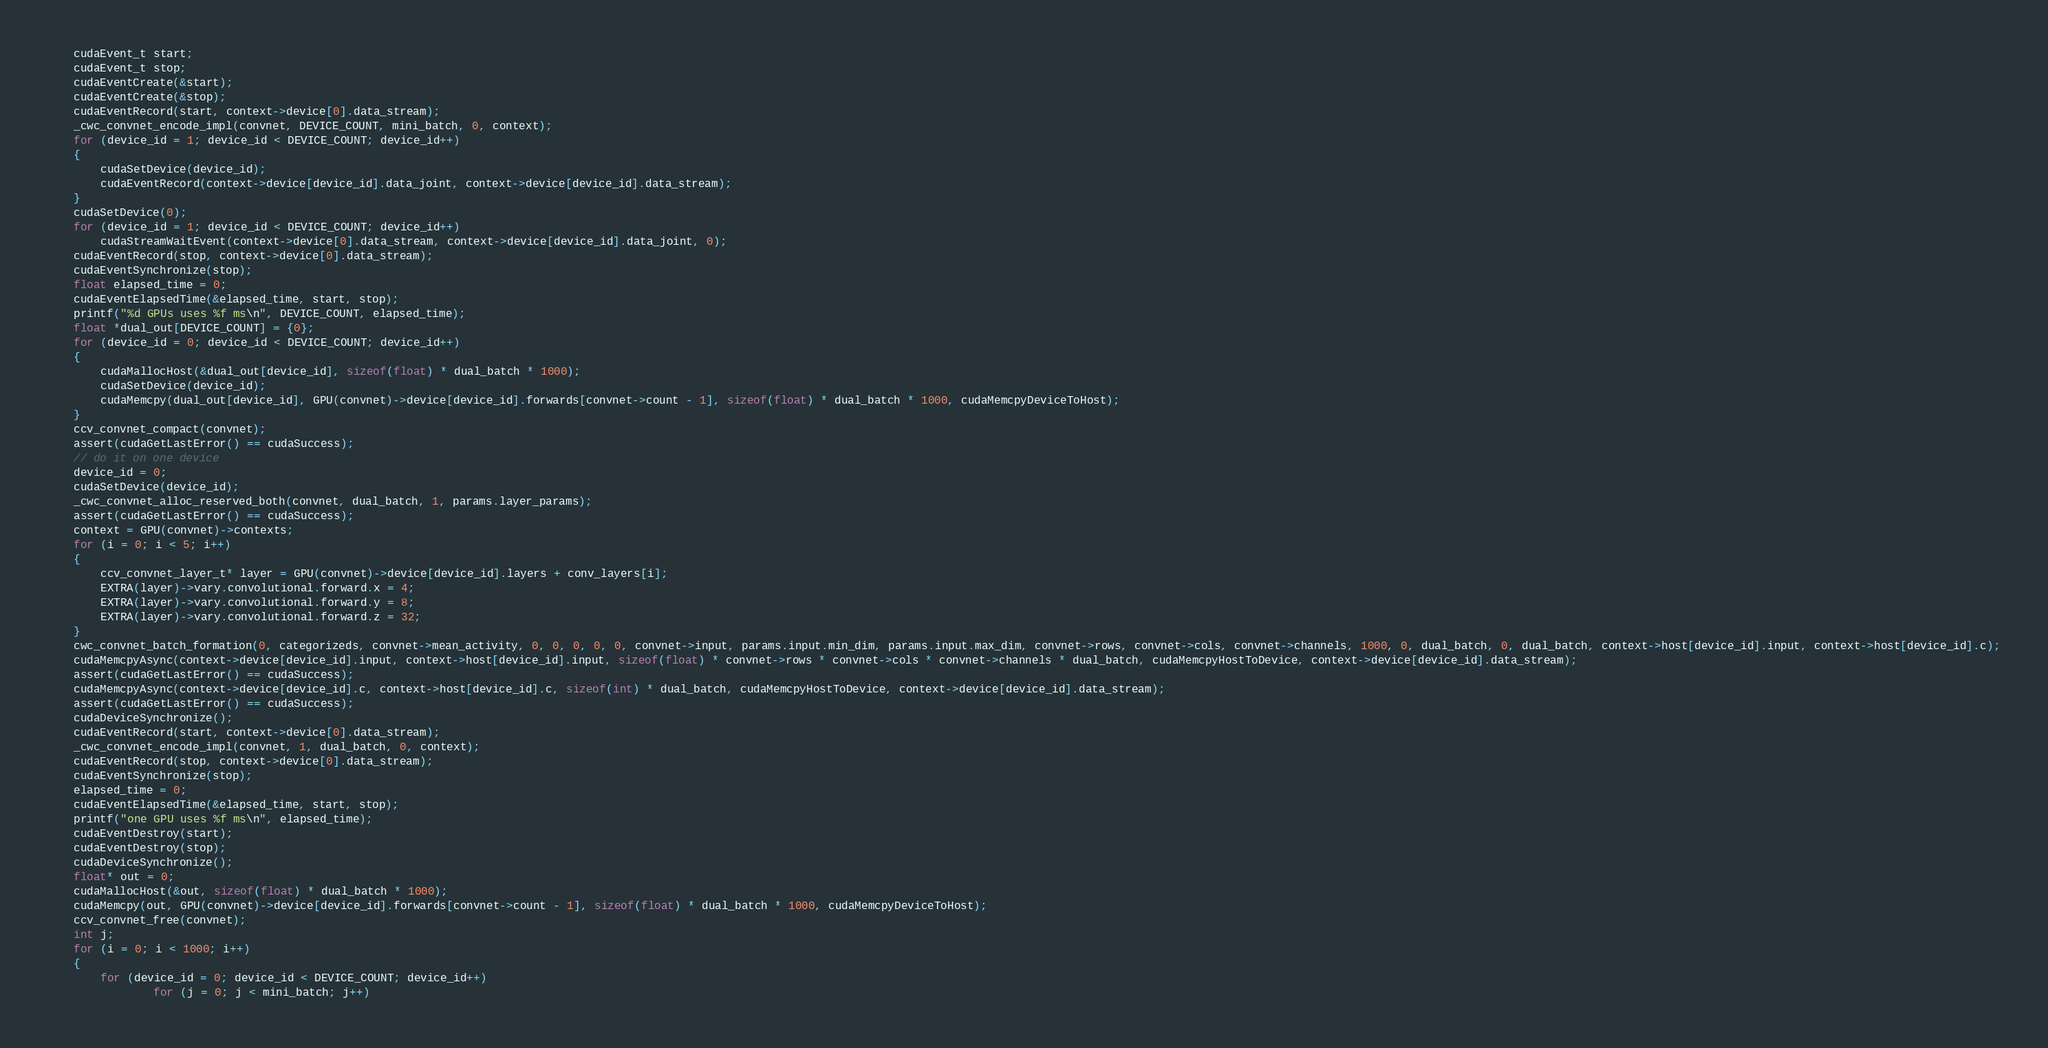Convert code to text. <code><loc_0><loc_0><loc_500><loc_500><_Cuda_>	cudaEvent_t start;
	cudaEvent_t stop;
	cudaEventCreate(&start);
	cudaEventCreate(&stop);
	cudaEventRecord(start, context->device[0].data_stream);
	_cwc_convnet_encode_impl(convnet, DEVICE_COUNT, mini_batch, 0, context);
	for (device_id = 1; device_id < DEVICE_COUNT; device_id++)
	{
		cudaSetDevice(device_id);
		cudaEventRecord(context->device[device_id].data_joint, context->device[device_id].data_stream);
	}
	cudaSetDevice(0);
	for (device_id = 1; device_id < DEVICE_COUNT; device_id++)
		cudaStreamWaitEvent(context->device[0].data_stream, context->device[device_id].data_joint, 0);
	cudaEventRecord(stop, context->device[0].data_stream);
	cudaEventSynchronize(stop);
	float elapsed_time = 0;
	cudaEventElapsedTime(&elapsed_time, start, stop);
	printf("%d GPUs uses %f ms\n", DEVICE_COUNT, elapsed_time);
	float *dual_out[DEVICE_COUNT] = {0};
	for (device_id = 0; device_id < DEVICE_COUNT; device_id++)
	{
		cudaMallocHost(&dual_out[device_id], sizeof(float) * dual_batch * 1000);
		cudaSetDevice(device_id);
		cudaMemcpy(dual_out[device_id], GPU(convnet)->device[device_id].forwards[convnet->count - 1], sizeof(float) * dual_batch * 1000, cudaMemcpyDeviceToHost);
	}
	ccv_convnet_compact(convnet);
	assert(cudaGetLastError() == cudaSuccess);
	// do it on one device
	device_id = 0;
	cudaSetDevice(device_id);
	_cwc_convnet_alloc_reserved_both(convnet, dual_batch, 1, params.layer_params);
	assert(cudaGetLastError() == cudaSuccess);
	context = GPU(convnet)->contexts;
	for (i = 0; i < 5; i++)
	{
		ccv_convnet_layer_t* layer = GPU(convnet)->device[device_id].layers + conv_layers[i];
		EXTRA(layer)->vary.convolutional.forward.x = 4;
		EXTRA(layer)->vary.convolutional.forward.y = 8;
		EXTRA(layer)->vary.convolutional.forward.z = 32;
	}
	cwc_convnet_batch_formation(0, categorizeds, convnet->mean_activity, 0, 0, 0, 0, 0, convnet->input, params.input.min_dim, params.input.max_dim, convnet->rows, convnet->cols, convnet->channels, 1000, 0, dual_batch, 0, dual_batch, context->host[device_id].input, context->host[device_id].c);
	cudaMemcpyAsync(context->device[device_id].input, context->host[device_id].input, sizeof(float) * convnet->rows * convnet->cols * convnet->channels * dual_batch, cudaMemcpyHostToDevice, context->device[device_id].data_stream);
	assert(cudaGetLastError() == cudaSuccess);
	cudaMemcpyAsync(context->device[device_id].c, context->host[device_id].c, sizeof(int) * dual_batch, cudaMemcpyHostToDevice, context->device[device_id].data_stream);
	assert(cudaGetLastError() == cudaSuccess);
	cudaDeviceSynchronize();
	cudaEventRecord(start, context->device[0].data_stream);
	_cwc_convnet_encode_impl(convnet, 1, dual_batch, 0, context);
	cudaEventRecord(stop, context->device[0].data_stream);
	cudaEventSynchronize(stop);
	elapsed_time = 0;
	cudaEventElapsedTime(&elapsed_time, start, stop);
	printf("one GPU uses %f ms\n", elapsed_time);
	cudaEventDestroy(start);
	cudaEventDestroy(stop);
	cudaDeviceSynchronize();
	float* out = 0;
	cudaMallocHost(&out, sizeof(float) * dual_batch * 1000);
	cudaMemcpy(out, GPU(convnet)->device[device_id].forwards[convnet->count - 1], sizeof(float) * dual_batch * 1000, cudaMemcpyDeviceToHost);
	ccv_convnet_free(convnet);
	int j;
	for (i = 0; i < 1000; i++)
	{
		for (device_id = 0; device_id < DEVICE_COUNT; device_id++)
				for (j = 0; j < mini_batch; j++)</code> 